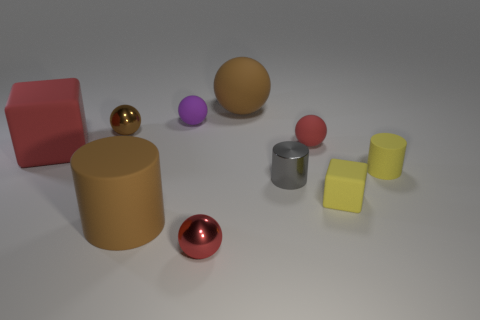Subtract all small metal spheres. How many spheres are left? 3 Subtract 1 cylinders. How many cylinders are left? 2 Subtract all red balls. How many balls are left? 3 Subtract all cylinders. How many objects are left? 7 Subtract all blue balls. Subtract all gray cylinders. How many balls are left? 5 Subtract all purple spheres. How many yellow cylinders are left? 1 Subtract all big cylinders. Subtract all purple matte things. How many objects are left? 8 Add 7 gray cylinders. How many gray cylinders are left? 8 Add 3 tiny yellow cubes. How many tiny yellow cubes exist? 4 Subtract 0 brown cubes. How many objects are left? 10 